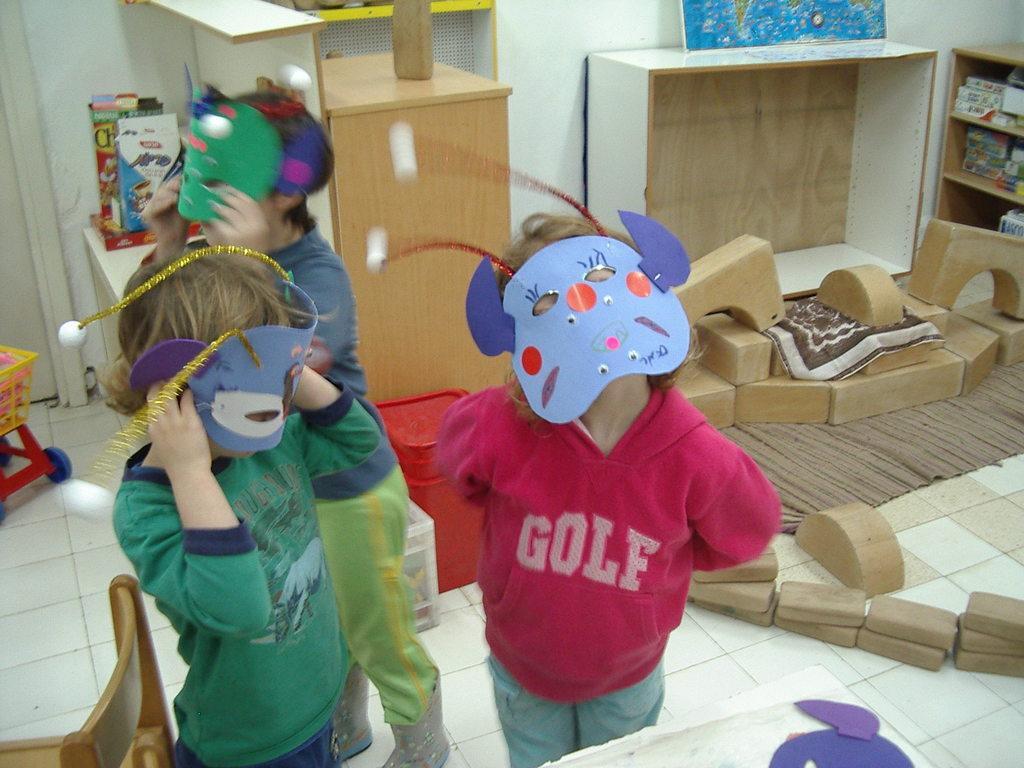Describe this image in one or two sentences. There is a room. They are standing in a room. They are holding a mask. They are wearing a mask. They are wearing a colorful shirts. We can see in background cupboard and poster. 